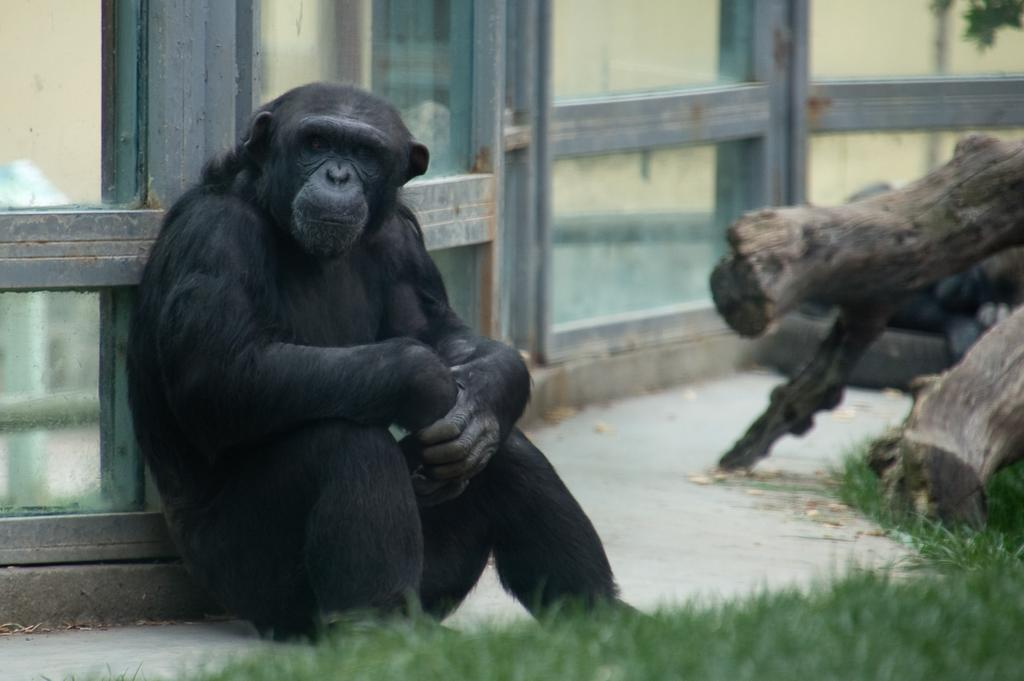What animal is in the foreground of the image? There is a chimpanzee in the foreground of the image. What is the chimpanzee doing in the image? The chimpanzee is sitting and leaning against a glass wall. What type of vegetation can be seen in the image? There is grass visible in the image, and trees with visible trunks can also be seen. What type of desk can be seen in the image? There is no desk present in the image. Can you describe the branch that the chimpanzee is holding in the image? There is no branch visible in the image; the chimpanzee is leaning against a glass wall. 